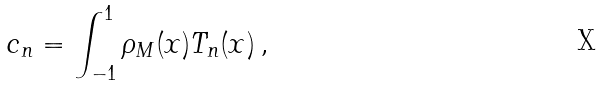<formula> <loc_0><loc_0><loc_500><loc_500>c _ { n } = \int _ { - 1 } ^ { 1 } \rho _ { M } ( x ) T _ { n } ( x ) \, ,</formula> 